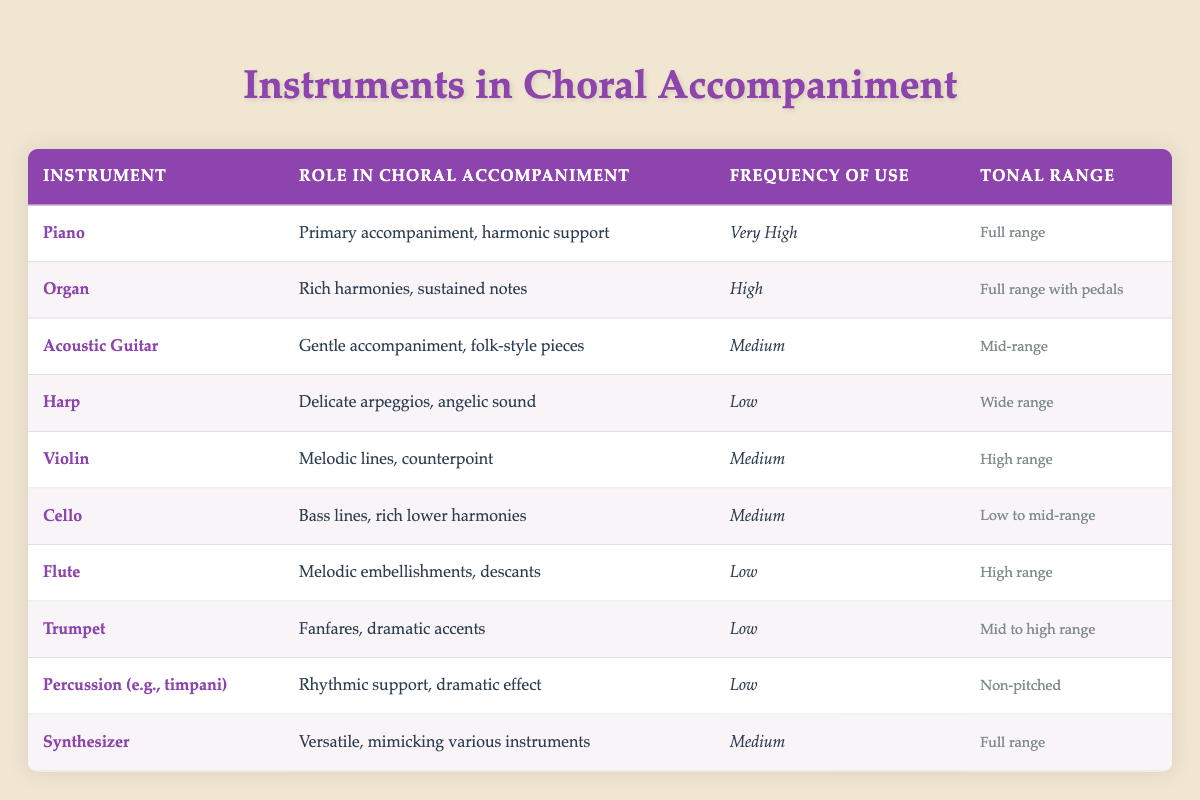What is the primary role of the piano in choral accompaniment? The table specifies that the piano serves as "Primary accompaniment, harmonic support," indicating its fundamental function in choral settings.
Answer: Primary accompaniment, harmonic support Which instrument has the highest frequency of use in choral accompaniment? From the table, the "Piano" is listed with a frequency of use marked as "Very High," which is the highest amongst all listed instruments.
Answer: Piano Is the cello used for melodic lines in choral accompaniment? According to the table, the role of the cello is identified as "Bass lines, rich lower harmonies," indicating it is not primarily used for melodic lines.
Answer: No How many instruments have a tonal range that is not full? Assessing the tonal ranges in the table, "Harp" (Wide range), "Cello" (Low to mid-range), "Flute" (High range), "Trumpet" (Mid to high range), and "Percussion" (Non-pitched) all have ranges that are not full. There are five such instruments identified.
Answer: 5 What is the average frequency of use for the instruments categorized as "Low"? There are four instruments considered "Low": Harp, Flute, Trumpet, and Percussion. The frequencies are Low for all instruments, meaning their collective frequency sum equals to 4 (but not numerically counted in a typical average sense). Thus, based on this context, the average would still be termed Low.
Answer: Low Which instrument is noted for rich harmonies and sustained notes? Upon reviewing the table, the "Organ" is noted specifically for providing "Rich harmonies, sustained notes" in its role, making it distinct for this characteristic.
Answer: Organ Is the synthesizer capable of mimicking various other instruments? The table explicitly states that the synthesizer's role is "Versatile, mimicking various instruments," which confirms that it can perform this function.
Answer: Yes How many instruments are categorized as having a medium frequency of use? Consulting the table, the instruments with a medium frequency of use are "Acoustic Guitar," "Violin," "Cello," and "Synthesizer," making a total of four instruments.
Answer: 4 